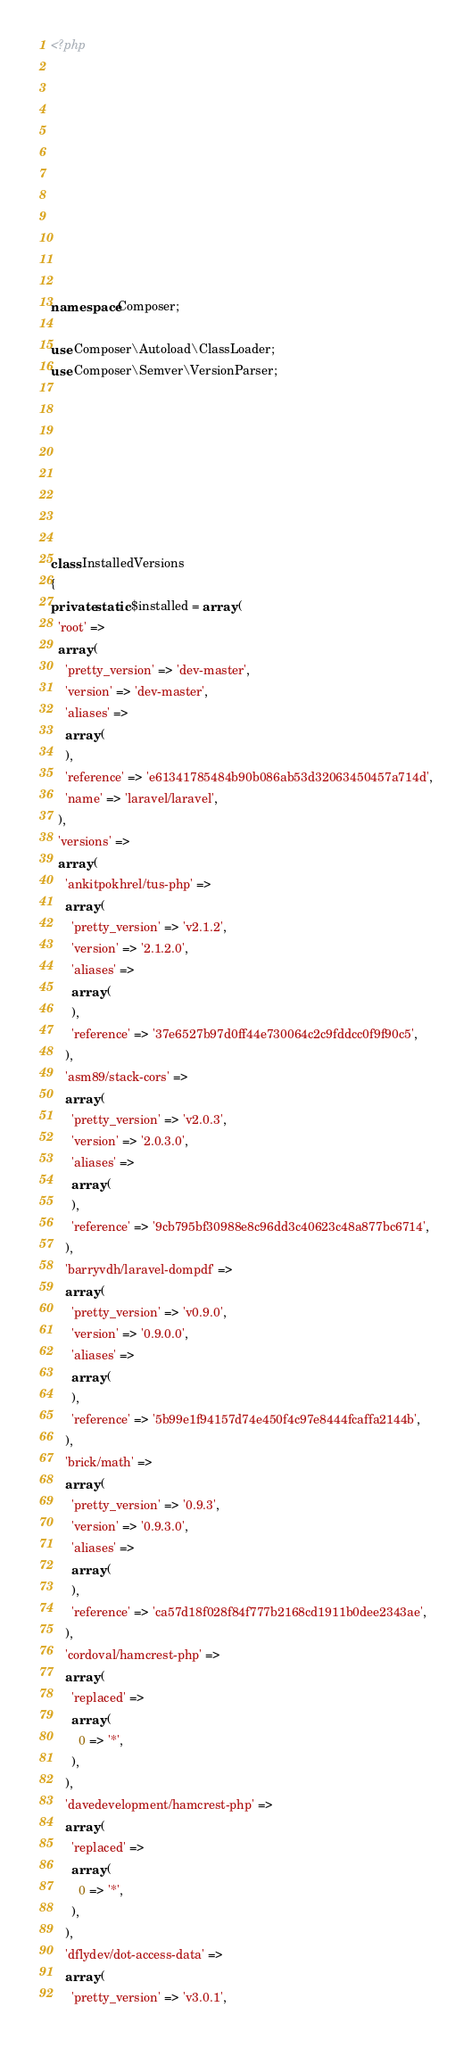Convert code to text. <code><loc_0><loc_0><loc_500><loc_500><_PHP_><?php











namespace Composer;

use Composer\Autoload\ClassLoader;
use Composer\Semver\VersionParser;








class InstalledVersions
{
private static $installed = array (
  'root' => 
  array (
    'pretty_version' => 'dev-master',
    'version' => 'dev-master',
    'aliases' => 
    array (
    ),
    'reference' => 'e61341785484b90b086ab53d32063450457a714d',
    'name' => 'laravel/laravel',
  ),
  'versions' => 
  array (
    'ankitpokhrel/tus-php' => 
    array (
      'pretty_version' => 'v2.1.2',
      'version' => '2.1.2.0',
      'aliases' => 
      array (
      ),
      'reference' => '37e6527b97d0ff44e730064c2c9fddcc0f9f90c5',
    ),
    'asm89/stack-cors' => 
    array (
      'pretty_version' => 'v2.0.3',
      'version' => '2.0.3.0',
      'aliases' => 
      array (
      ),
      'reference' => '9cb795bf30988e8c96dd3c40623c48a877bc6714',
    ),
    'barryvdh/laravel-dompdf' => 
    array (
      'pretty_version' => 'v0.9.0',
      'version' => '0.9.0.0',
      'aliases' => 
      array (
      ),
      'reference' => '5b99e1f94157d74e450f4c97e8444fcaffa2144b',
    ),
    'brick/math' => 
    array (
      'pretty_version' => '0.9.3',
      'version' => '0.9.3.0',
      'aliases' => 
      array (
      ),
      'reference' => 'ca57d18f028f84f777b2168cd1911b0dee2343ae',
    ),
    'cordoval/hamcrest-php' => 
    array (
      'replaced' => 
      array (
        0 => '*',
      ),
    ),
    'davedevelopment/hamcrest-php' => 
    array (
      'replaced' => 
      array (
        0 => '*',
      ),
    ),
    'dflydev/dot-access-data' => 
    array (
      'pretty_version' => 'v3.0.1',</code> 